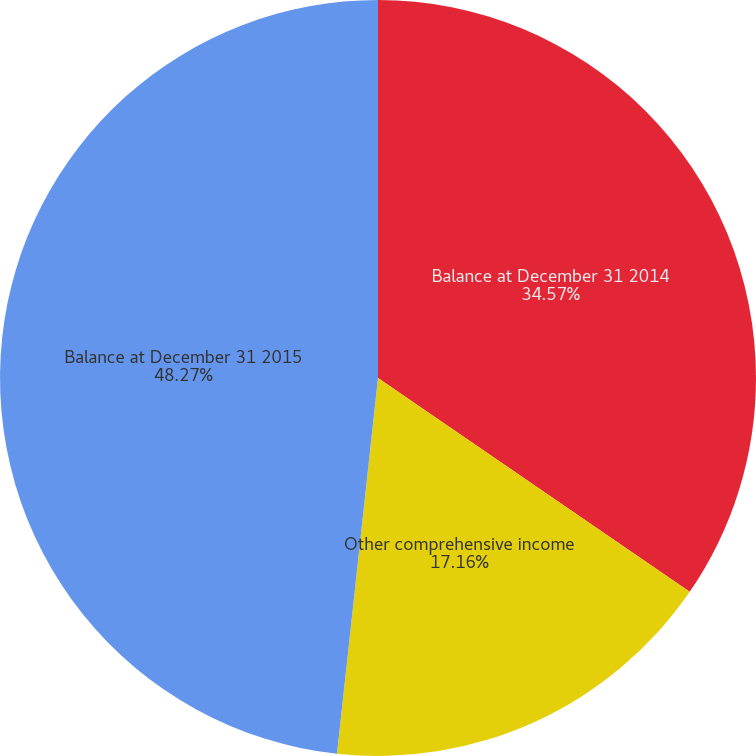<chart> <loc_0><loc_0><loc_500><loc_500><pie_chart><fcel>Balance at December 31 2014<fcel>Other comprehensive income<fcel>Balance at December 31 2015<nl><fcel>34.57%<fcel>17.16%<fcel>48.27%<nl></chart> 